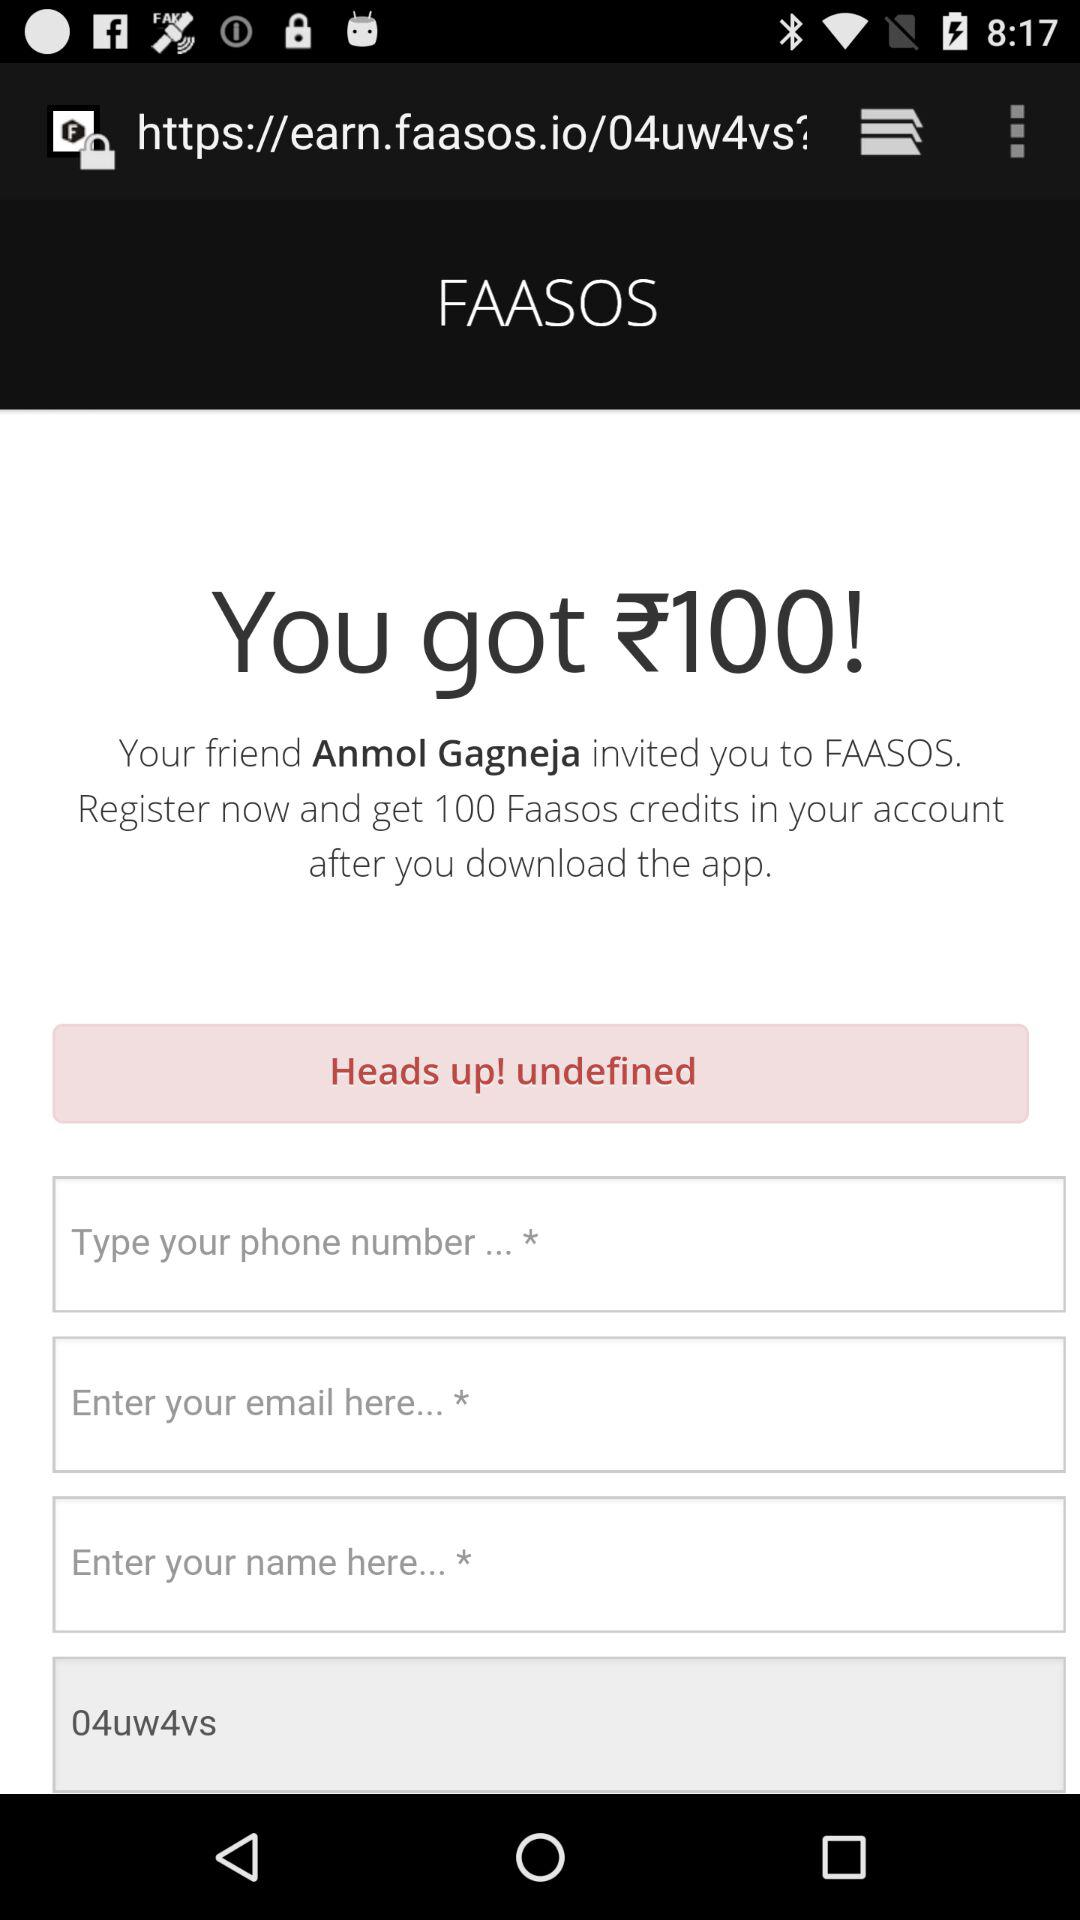What is the entered email address?
When the provided information is insufficient, respond with <no answer>. <no answer> 